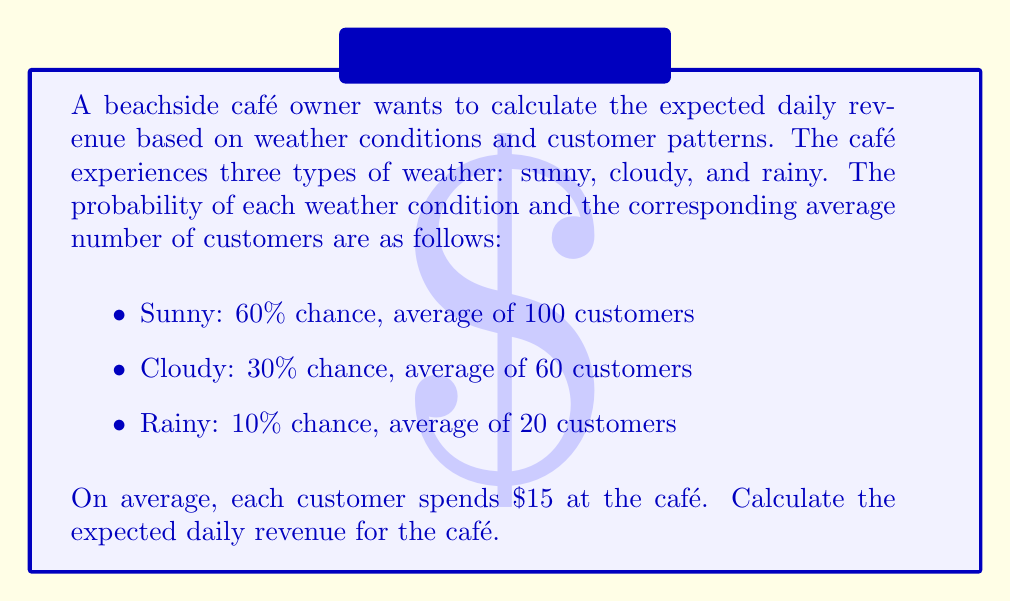Give your solution to this math problem. To calculate the expected daily revenue, we need to follow these steps:

1. Calculate the expected number of customers for each weather condition:
   - Sunny: $0.60 \times 100 = 60$ customers
   - Cloudy: $0.30 \times 60 = 18$ customers
   - Rainy: $0.10 \times 20 = 2$ customers

2. Sum up the expected number of customers:
   $60 + 18 + 2 = 80$ total expected customers

3. Calculate the expected revenue:
   Let $R$ be the expected daily revenue.
   $$R = 80 \text{ customers} \times \$15\text{ per customer} = \$1200$$

Therefore, the expected daily revenue for the café is $1200.
Answer: $1200 